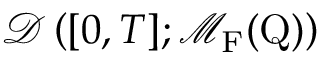<formula> <loc_0><loc_0><loc_500><loc_500>\mathcal { D } \left ( [ 0 , T ] ; \mathcal { M } _ { F } ( Q ) \right )</formula> 